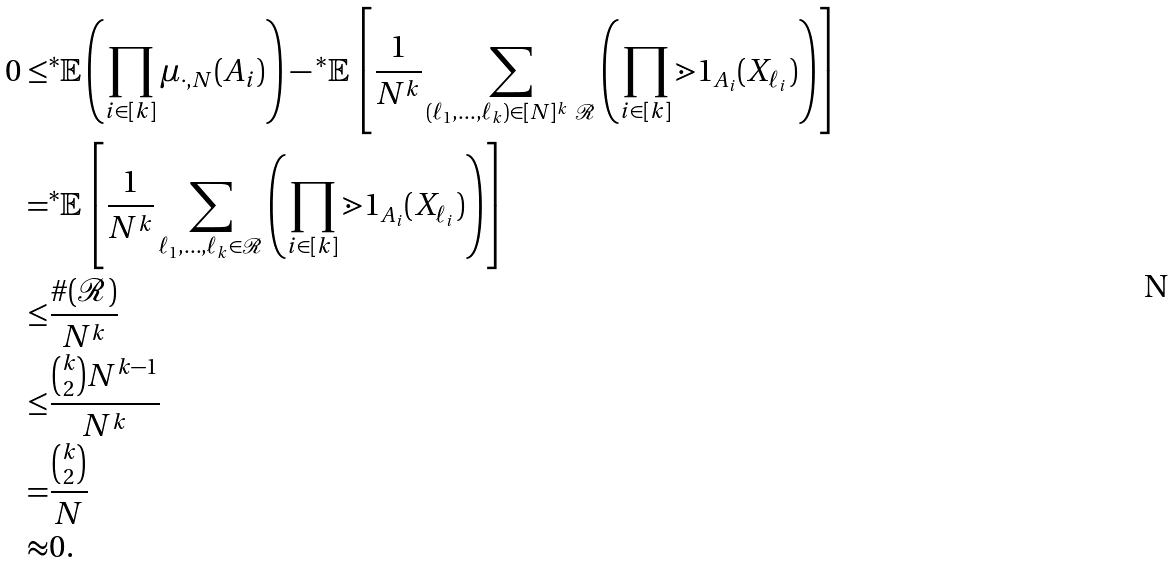Convert formula to latex. <formula><loc_0><loc_0><loc_500><loc_500>0 \leq & { ^ { * } } \mathbb { E } \left ( \prod _ { i \in [ k ] } \mu _ { \cdot , N } ( A _ { i } ) \right ) - { ^ { * } } \mathbb { E } \left [ \frac { 1 } { N ^ { k } } \sum _ { ( \ell _ { 1 } , \dots , \ell _ { k } ) \in [ N ] ^ { k } \ \mathcal { R } } \left ( \prod _ { i \in [ k ] } \mathbb { m } { 1 } _ { A _ { i } } ( X _ { \ell _ { i } } ) \right ) \right ] \\ = & { ^ { * } } \mathbb { E } \left [ \frac { 1 } { N ^ { k } } \sum _ { \ell _ { 1 } , \dots , \ell _ { k } \in \mathcal { R } } \left ( \prod _ { i \in [ k ] } \mathbb { m } { 1 } _ { A _ { i } } ( X _ { \ell _ { i } } ) \right ) \right ] \\ \leq & \frac { \# ( \mathcal { R } ) } { N ^ { k } } \\ \leq & \frac { \binom { k } { 2 } N ^ { k - 1 } } { N ^ { k } } \\ = & \frac { \binom { k } { 2 } } { N } \\ \approx & 0 .</formula> 